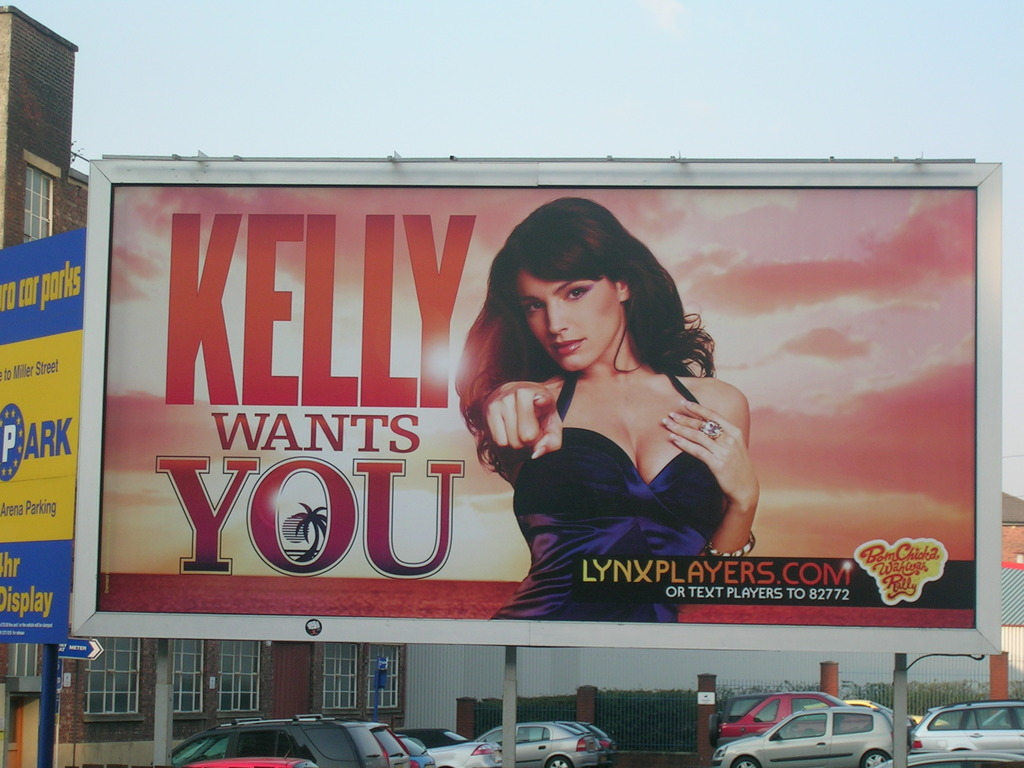What is the primary message of this advertisement and how might it appeal to its target audience? The primary message of the advertisement with 'Kelly Wants You' aims to attract attention through personal appeal and direct engagement. The inclusion of an attractive female figure and the direct call to action likely aim to captivate a young, perhaps predominantly male audience, which can be inferred by the styling and tone of the ad. 